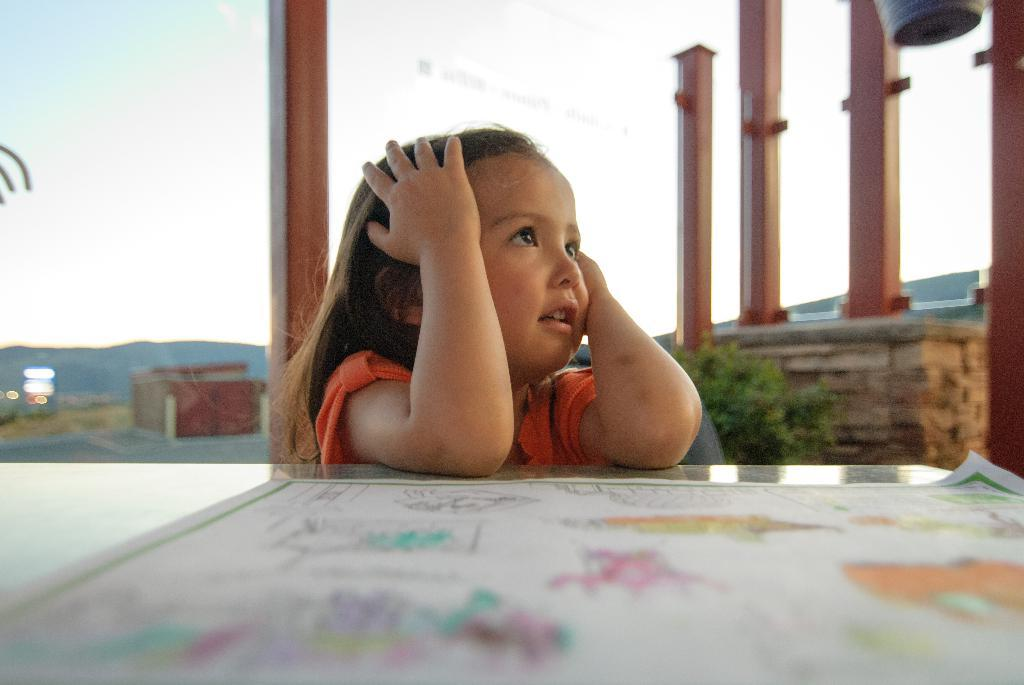Who is the main subject in the image? There is a small girl in the image. What is the girl doing in the image? The girl is sitting on a chair. What is in front of the girl on the table? There is a chart in front of the girl on a table. What can be seen behind the girl in the image? The sky is visible behind the girl. How many iron poles are present in the image? There are four iron poles in the image. What type of needle is the girl using to sew in the image? There is no needle present in the image, and the girl is not sewing. 